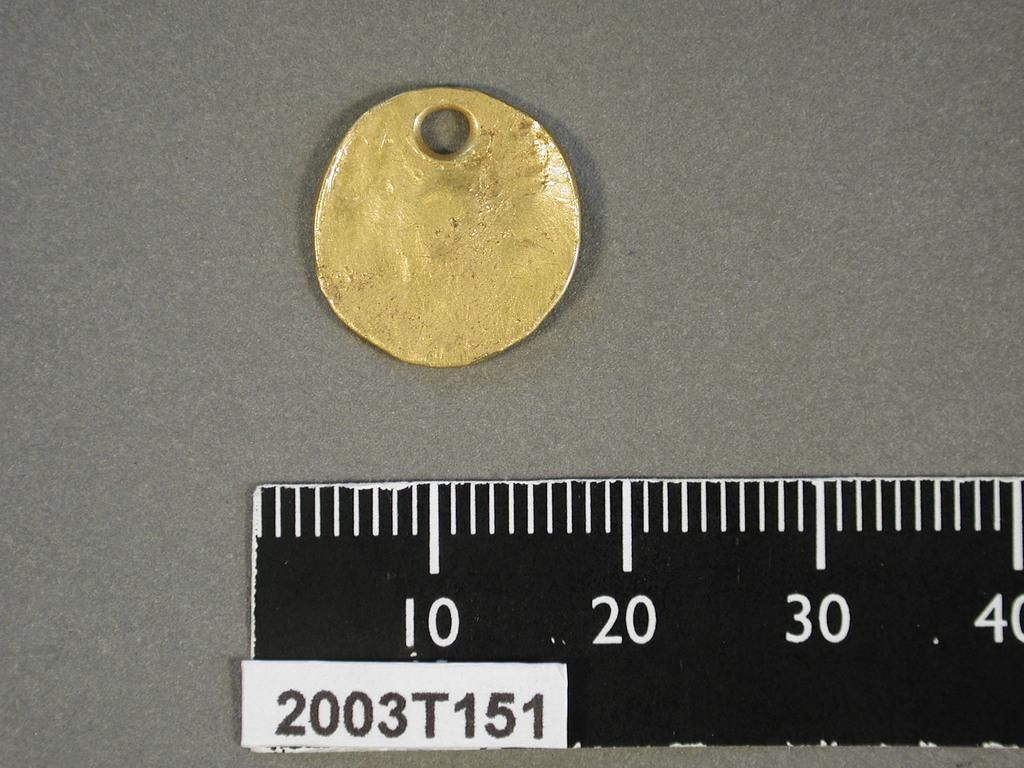Provide a one-sentence caption for the provided image. A gold colored metal item is above the 10 reading on the ruler. 